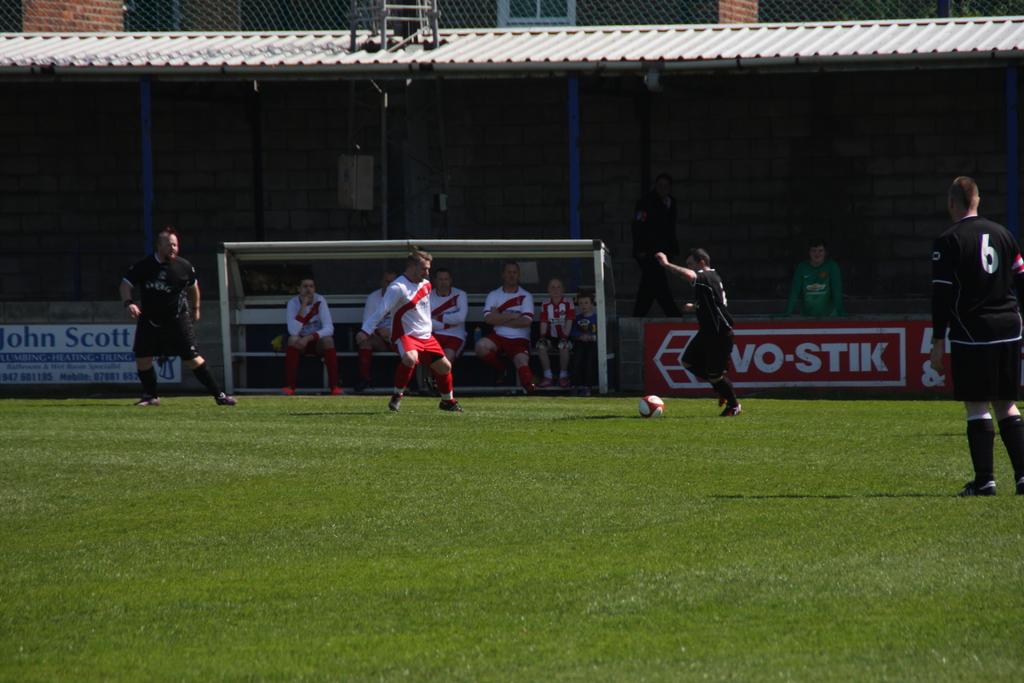What is the man on the rights jersey number?
Offer a very short reply. 6. 